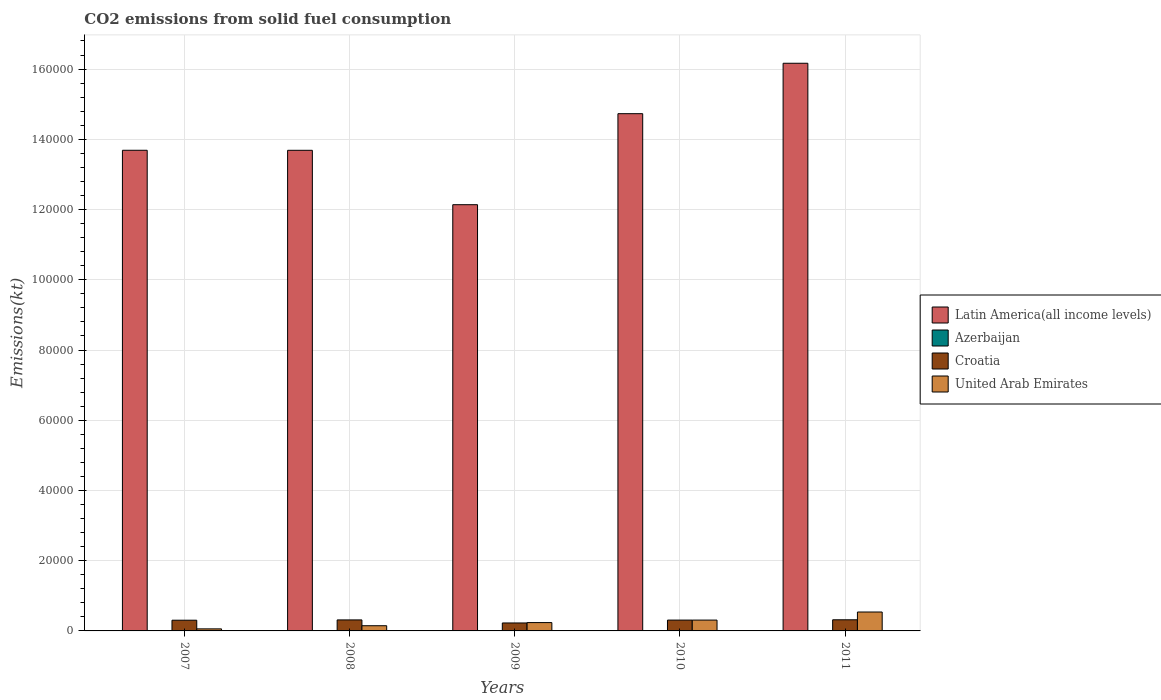Are the number of bars per tick equal to the number of legend labels?
Ensure brevity in your answer.  Yes. How many bars are there on the 5th tick from the left?
Make the answer very short. 4. What is the amount of CO2 emitted in Latin America(all income levels) in 2008?
Keep it short and to the point. 1.37e+05. Across all years, what is the maximum amount of CO2 emitted in Latin America(all income levels)?
Ensure brevity in your answer.  1.62e+05. Across all years, what is the minimum amount of CO2 emitted in Croatia?
Offer a terse response. 2266.21. In which year was the amount of CO2 emitted in Azerbaijan maximum?
Make the answer very short. 2007. In which year was the amount of CO2 emitted in Croatia minimum?
Make the answer very short. 2009. What is the total amount of CO2 emitted in United Arab Emirates in the graph?
Your answer should be very brief. 1.29e+04. What is the difference between the amount of CO2 emitted in Croatia in 2010 and that in 2011?
Give a very brief answer. -80.67. What is the difference between the amount of CO2 emitted in Latin America(all income levels) in 2011 and the amount of CO2 emitted in Azerbaijan in 2009?
Keep it short and to the point. 1.62e+05. What is the average amount of CO2 emitted in Latin America(all income levels) per year?
Offer a terse response. 1.41e+05. In the year 2011, what is the difference between the amount of CO2 emitted in United Arab Emirates and amount of CO2 emitted in Azerbaijan?
Ensure brevity in your answer.  5364.82. What is the ratio of the amount of CO2 emitted in Croatia in 2007 to that in 2011?
Offer a terse response. 0.96. Is the amount of CO2 emitted in United Arab Emirates in 2007 less than that in 2010?
Provide a short and direct response. Yes. What is the difference between the highest and the second highest amount of CO2 emitted in Azerbaijan?
Give a very brief answer. 0. What is the difference between the highest and the lowest amount of CO2 emitted in United Arab Emirates?
Your response must be concise. 4803.77. What does the 2nd bar from the left in 2010 represents?
Your answer should be compact. Azerbaijan. What does the 4th bar from the right in 2007 represents?
Keep it short and to the point. Latin America(all income levels). Is it the case that in every year, the sum of the amount of CO2 emitted in United Arab Emirates and amount of CO2 emitted in Azerbaijan is greater than the amount of CO2 emitted in Latin America(all income levels)?
Offer a terse response. No. Are all the bars in the graph horizontal?
Your response must be concise. No. What is the difference between two consecutive major ticks on the Y-axis?
Offer a very short reply. 2.00e+04. Does the graph contain any zero values?
Your answer should be very brief. No. Does the graph contain grids?
Give a very brief answer. Yes. How many legend labels are there?
Keep it short and to the point. 4. What is the title of the graph?
Make the answer very short. CO2 emissions from solid fuel consumption. What is the label or title of the Y-axis?
Offer a terse response. Emissions(kt). What is the Emissions(kt) in Latin America(all income levels) in 2007?
Give a very brief answer. 1.37e+05. What is the Emissions(kt) of Azerbaijan in 2007?
Give a very brief answer. 22. What is the Emissions(kt) of Croatia in 2007?
Your answer should be very brief. 3050.94. What is the Emissions(kt) in United Arab Emirates in 2007?
Offer a very short reply. 583.05. What is the Emissions(kt) of Latin America(all income levels) in 2008?
Provide a succinct answer. 1.37e+05. What is the Emissions(kt) in Azerbaijan in 2008?
Offer a terse response. 14.67. What is the Emissions(kt) of Croatia in 2008?
Provide a succinct answer. 3135.28. What is the Emissions(kt) of United Arab Emirates in 2008?
Your answer should be very brief. 1477.8. What is the Emissions(kt) in Latin America(all income levels) in 2009?
Make the answer very short. 1.21e+05. What is the Emissions(kt) in Azerbaijan in 2009?
Offer a very short reply. 14.67. What is the Emissions(kt) in Croatia in 2009?
Your answer should be compact. 2266.21. What is the Emissions(kt) in United Arab Emirates in 2009?
Your response must be concise. 2372.55. What is the Emissions(kt) of Latin America(all income levels) in 2010?
Your response must be concise. 1.47e+05. What is the Emissions(kt) of Azerbaijan in 2010?
Offer a terse response. 22. What is the Emissions(kt) in Croatia in 2010?
Offer a terse response. 3087.61. What is the Emissions(kt) of United Arab Emirates in 2010?
Provide a short and direct response. 3083.95. What is the Emissions(kt) of Latin America(all income levels) in 2011?
Your answer should be very brief. 1.62e+05. What is the Emissions(kt) in Azerbaijan in 2011?
Your response must be concise. 22. What is the Emissions(kt) of Croatia in 2011?
Your answer should be very brief. 3168.29. What is the Emissions(kt) in United Arab Emirates in 2011?
Give a very brief answer. 5386.82. Across all years, what is the maximum Emissions(kt) of Latin America(all income levels)?
Provide a succinct answer. 1.62e+05. Across all years, what is the maximum Emissions(kt) in Azerbaijan?
Offer a very short reply. 22. Across all years, what is the maximum Emissions(kt) of Croatia?
Your response must be concise. 3168.29. Across all years, what is the maximum Emissions(kt) of United Arab Emirates?
Your answer should be compact. 5386.82. Across all years, what is the minimum Emissions(kt) in Latin America(all income levels)?
Keep it short and to the point. 1.21e+05. Across all years, what is the minimum Emissions(kt) of Azerbaijan?
Your response must be concise. 14.67. Across all years, what is the minimum Emissions(kt) of Croatia?
Provide a succinct answer. 2266.21. Across all years, what is the minimum Emissions(kt) in United Arab Emirates?
Keep it short and to the point. 583.05. What is the total Emissions(kt) in Latin America(all income levels) in the graph?
Your answer should be very brief. 7.04e+05. What is the total Emissions(kt) in Azerbaijan in the graph?
Offer a terse response. 95.34. What is the total Emissions(kt) of Croatia in the graph?
Offer a terse response. 1.47e+04. What is the total Emissions(kt) in United Arab Emirates in the graph?
Your answer should be very brief. 1.29e+04. What is the difference between the Emissions(kt) in Latin America(all income levels) in 2007 and that in 2008?
Keep it short and to the point. 7.81. What is the difference between the Emissions(kt) of Azerbaijan in 2007 and that in 2008?
Provide a short and direct response. 7.33. What is the difference between the Emissions(kt) of Croatia in 2007 and that in 2008?
Your response must be concise. -84.34. What is the difference between the Emissions(kt) in United Arab Emirates in 2007 and that in 2008?
Provide a short and direct response. -894.75. What is the difference between the Emissions(kt) of Latin America(all income levels) in 2007 and that in 2009?
Offer a very short reply. 1.55e+04. What is the difference between the Emissions(kt) in Azerbaijan in 2007 and that in 2009?
Ensure brevity in your answer.  7.33. What is the difference between the Emissions(kt) of Croatia in 2007 and that in 2009?
Ensure brevity in your answer.  784.74. What is the difference between the Emissions(kt) in United Arab Emirates in 2007 and that in 2009?
Ensure brevity in your answer.  -1789.5. What is the difference between the Emissions(kt) in Latin America(all income levels) in 2007 and that in 2010?
Ensure brevity in your answer.  -1.04e+04. What is the difference between the Emissions(kt) of Croatia in 2007 and that in 2010?
Your answer should be compact. -36.67. What is the difference between the Emissions(kt) of United Arab Emirates in 2007 and that in 2010?
Make the answer very short. -2500.89. What is the difference between the Emissions(kt) in Latin America(all income levels) in 2007 and that in 2011?
Provide a succinct answer. -2.48e+04. What is the difference between the Emissions(kt) of Croatia in 2007 and that in 2011?
Keep it short and to the point. -117.34. What is the difference between the Emissions(kt) in United Arab Emirates in 2007 and that in 2011?
Ensure brevity in your answer.  -4803.77. What is the difference between the Emissions(kt) in Latin America(all income levels) in 2008 and that in 2009?
Your answer should be compact. 1.55e+04. What is the difference between the Emissions(kt) in Croatia in 2008 and that in 2009?
Provide a succinct answer. 869.08. What is the difference between the Emissions(kt) in United Arab Emirates in 2008 and that in 2009?
Your answer should be very brief. -894.75. What is the difference between the Emissions(kt) in Latin America(all income levels) in 2008 and that in 2010?
Make the answer very short. -1.04e+04. What is the difference between the Emissions(kt) in Azerbaijan in 2008 and that in 2010?
Ensure brevity in your answer.  -7.33. What is the difference between the Emissions(kt) in Croatia in 2008 and that in 2010?
Provide a succinct answer. 47.67. What is the difference between the Emissions(kt) of United Arab Emirates in 2008 and that in 2010?
Your answer should be very brief. -1606.15. What is the difference between the Emissions(kt) in Latin America(all income levels) in 2008 and that in 2011?
Ensure brevity in your answer.  -2.48e+04. What is the difference between the Emissions(kt) in Azerbaijan in 2008 and that in 2011?
Give a very brief answer. -7.33. What is the difference between the Emissions(kt) of Croatia in 2008 and that in 2011?
Provide a succinct answer. -33. What is the difference between the Emissions(kt) in United Arab Emirates in 2008 and that in 2011?
Your answer should be very brief. -3909.02. What is the difference between the Emissions(kt) of Latin America(all income levels) in 2009 and that in 2010?
Your answer should be compact. -2.59e+04. What is the difference between the Emissions(kt) of Azerbaijan in 2009 and that in 2010?
Ensure brevity in your answer.  -7.33. What is the difference between the Emissions(kt) of Croatia in 2009 and that in 2010?
Give a very brief answer. -821.41. What is the difference between the Emissions(kt) in United Arab Emirates in 2009 and that in 2010?
Provide a short and direct response. -711.4. What is the difference between the Emissions(kt) in Latin America(all income levels) in 2009 and that in 2011?
Provide a succinct answer. -4.03e+04. What is the difference between the Emissions(kt) of Azerbaijan in 2009 and that in 2011?
Offer a terse response. -7.33. What is the difference between the Emissions(kt) of Croatia in 2009 and that in 2011?
Offer a terse response. -902.08. What is the difference between the Emissions(kt) of United Arab Emirates in 2009 and that in 2011?
Provide a short and direct response. -3014.27. What is the difference between the Emissions(kt) of Latin America(all income levels) in 2010 and that in 2011?
Your response must be concise. -1.44e+04. What is the difference between the Emissions(kt) in Croatia in 2010 and that in 2011?
Provide a short and direct response. -80.67. What is the difference between the Emissions(kt) of United Arab Emirates in 2010 and that in 2011?
Give a very brief answer. -2302.88. What is the difference between the Emissions(kt) of Latin America(all income levels) in 2007 and the Emissions(kt) of Azerbaijan in 2008?
Provide a short and direct response. 1.37e+05. What is the difference between the Emissions(kt) in Latin America(all income levels) in 2007 and the Emissions(kt) in Croatia in 2008?
Your answer should be compact. 1.34e+05. What is the difference between the Emissions(kt) in Latin America(all income levels) in 2007 and the Emissions(kt) in United Arab Emirates in 2008?
Your answer should be compact. 1.35e+05. What is the difference between the Emissions(kt) in Azerbaijan in 2007 and the Emissions(kt) in Croatia in 2008?
Offer a terse response. -3113.28. What is the difference between the Emissions(kt) of Azerbaijan in 2007 and the Emissions(kt) of United Arab Emirates in 2008?
Ensure brevity in your answer.  -1455.8. What is the difference between the Emissions(kt) of Croatia in 2007 and the Emissions(kt) of United Arab Emirates in 2008?
Your response must be concise. 1573.14. What is the difference between the Emissions(kt) of Latin America(all income levels) in 2007 and the Emissions(kt) of Azerbaijan in 2009?
Give a very brief answer. 1.37e+05. What is the difference between the Emissions(kt) in Latin America(all income levels) in 2007 and the Emissions(kt) in Croatia in 2009?
Give a very brief answer. 1.35e+05. What is the difference between the Emissions(kt) of Latin America(all income levels) in 2007 and the Emissions(kt) of United Arab Emirates in 2009?
Your answer should be compact. 1.35e+05. What is the difference between the Emissions(kt) of Azerbaijan in 2007 and the Emissions(kt) of Croatia in 2009?
Keep it short and to the point. -2244.2. What is the difference between the Emissions(kt) of Azerbaijan in 2007 and the Emissions(kt) of United Arab Emirates in 2009?
Your response must be concise. -2350.55. What is the difference between the Emissions(kt) in Croatia in 2007 and the Emissions(kt) in United Arab Emirates in 2009?
Your answer should be compact. 678.39. What is the difference between the Emissions(kt) of Latin America(all income levels) in 2007 and the Emissions(kt) of Azerbaijan in 2010?
Your answer should be very brief. 1.37e+05. What is the difference between the Emissions(kt) in Latin America(all income levels) in 2007 and the Emissions(kt) in Croatia in 2010?
Your answer should be very brief. 1.34e+05. What is the difference between the Emissions(kt) of Latin America(all income levels) in 2007 and the Emissions(kt) of United Arab Emirates in 2010?
Ensure brevity in your answer.  1.34e+05. What is the difference between the Emissions(kt) in Azerbaijan in 2007 and the Emissions(kt) in Croatia in 2010?
Give a very brief answer. -3065.61. What is the difference between the Emissions(kt) of Azerbaijan in 2007 and the Emissions(kt) of United Arab Emirates in 2010?
Your response must be concise. -3061.95. What is the difference between the Emissions(kt) of Croatia in 2007 and the Emissions(kt) of United Arab Emirates in 2010?
Make the answer very short. -33. What is the difference between the Emissions(kt) of Latin America(all income levels) in 2007 and the Emissions(kt) of Azerbaijan in 2011?
Offer a terse response. 1.37e+05. What is the difference between the Emissions(kt) of Latin America(all income levels) in 2007 and the Emissions(kt) of Croatia in 2011?
Your answer should be very brief. 1.34e+05. What is the difference between the Emissions(kt) of Latin America(all income levels) in 2007 and the Emissions(kt) of United Arab Emirates in 2011?
Ensure brevity in your answer.  1.31e+05. What is the difference between the Emissions(kt) of Azerbaijan in 2007 and the Emissions(kt) of Croatia in 2011?
Ensure brevity in your answer.  -3146.29. What is the difference between the Emissions(kt) in Azerbaijan in 2007 and the Emissions(kt) in United Arab Emirates in 2011?
Your answer should be very brief. -5364.82. What is the difference between the Emissions(kt) of Croatia in 2007 and the Emissions(kt) of United Arab Emirates in 2011?
Keep it short and to the point. -2335.88. What is the difference between the Emissions(kt) of Latin America(all income levels) in 2008 and the Emissions(kt) of Azerbaijan in 2009?
Your response must be concise. 1.37e+05. What is the difference between the Emissions(kt) in Latin America(all income levels) in 2008 and the Emissions(kt) in Croatia in 2009?
Keep it short and to the point. 1.35e+05. What is the difference between the Emissions(kt) in Latin America(all income levels) in 2008 and the Emissions(kt) in United Arab Emirates in 2009?
Give a very brief answer. 1.34e+05. What is the difference between the Emissions(kt) of Azerbaijan in 2008 and the Emissions(kt) of Croatia in 2009?
Provide a short and direct response. -2251.54. What is the difference between the Emissions(kt) of Azerbaijan in 2008 and the Emissions(kt) of United Arab Emirates in 2009?
Ensure brevity in your answer.  -2357.88. What is the difference between the Emissions(kt) in Croatia in 2008 and the Emissions(kt) in United Arab Emirates in 2009?
Your answer should be compact. 762.74. What is the difference between the Emissions(kt) in Latin America(all income levels) in 2008 and the Emissions(kt) in Azerbaijan in 2010?
Offer a very short reply. 1.37e+05. What is the difference between the Emissions(kt) in Latin America(all income levels) in 2008 and the Emissions(kt) in Croatia in 2010?
Make the answer very short. 1.34e+05. What is the difference between the Emissions(kt) in Latin America(all income levels) in 2008 and the Emissions(kt) in United Arab Emirates in 2010?
Provide a short and direct response. 1.34e+05. What is the difference between the Emissions(kt) of Azerbaijan in 2008 and the Emissions(kt) of Croatia in 2010?
Your answer should be very brief. -3072.95. What is the difference between the Emissions(kt) of Azerbaijan in 2008 and the Emissions(kt) of United Arab Emirates in 2010?
Make the answer very short. -3069.28. What is the difference between the Emissions(kt) of Croatia in 2008 and the Emissions(kt) of United Arab Emirates in 2010?
Provide a short and direct response. 51.34. What is the difference between the Emissions(kt) of Latin America(all income levels) in 2008 and the Emissions(kt) of Azerbaijan in 2011?
Give a very brief answer. 1.37e+05. What is the difference between the Emissions(kt) in Latin America(all income levels) in 2008 and the Emissions(kt) in Croatia in 2011?
Give a very brief answer. 1.34e+05. What is the difference between the Emissions(kt) in Latin America(all income levels) in 2008 and the Emissions(kt) in United Arab Emirates in 2011?
Make the answer very short. 1.31e+05. What is the difference between the Emissions(kt) in Azerbaijan in 2008 and the Emissions(kt) in Croatia in 2011?
Provide a succinct answer. -3153.62. What is the difference between the Emissions(kt) of Azerbaijan in 2008 and the Emissions(kt) of United Arab Emirates in 2011?
Provide a short and direct response. -5372.15. What is the difference between the Emissions(kt) in Croatia in 2008 and the Emissions(kt) in United Arab Emirates in 2011?
Make the answer very short. -2251.54. What is the difference between the Emissions(kt) in Latin America(all income levels) in 2009 and the Emissions(kt) in Azerbaijan in 2010?
Keep it short and to the point. 1.21e+05. What is the difference between the Emissions(kt) in Latin America(all income levels) in 2009 and the Emissions(kt) in Croatia in 2010?
Provide a short and direct response. 1.18e+05. What is the difference between the Emissions(kt) in Latin America(all income levels) in 2009 and the Emissions(kt) in United Arab Emirates in 2010?
Keep it short and to the point. 1.18e+05. What is the difference between the Emissions(kt) in Azerbaijan in 2009 and the Emissions(kt) in Croatia in 2010?
Provide a succinct answer. -3072.95. What is the difference between the Emissions(kt) of Azerbaijan in 2009 and the Emissions(kt) of United Arab Emirates in 2010?
Provide a succinct answer. -3069.28. What is the difference between the Emissions(kt) in Croatia in 2009 and the Emissions(kt) in United Arab Emirates in 2010?
Keep it short and to the point. -817.74. What is the difference between the Emissions(kt) in Latin America(all income levels) in 2009 and the Emissions(kt) in Azerbaijan in 2011?
Offer a terse response. 1.21e+05. What is the difference between the Emissions(kt) in Latin America(all income levels) in 2009 and the Emissions(kt) in Croatia in 2011?
Give a very brief answer. 1.18e+05. What is the difference between the Emissions(kt) in Latin America(all income levels) in 2009 and the Emissions(kt) in United Arab Emirates in 2011?
Offer a terse response. 1.16e+05. What is the difference between the Emissions(kt) in Azerbaijan in 2009 and the Emissions(kt) in Croatia in 2011?
Ensure brevity in your answer.  -3153.62. What is the difference between the Emissions(kt) in Azerbaijan in 2009 and the Emissions(kt) in United Arab Emirates in 2011?
Provide a succinct answer. -5372.15. What is the difference between the Emissions(kt) in Croatia in 2009 and the Emissions(kt) in United Arab Emirates in 2011?
Your answer should be very brief. -3120.62. What is the difference between the Emissions(kt) in Latin America(all income levels) in 2010 and the Emissions(kt) in Azerbaijan in 2011?
Your answer should be very brief. 1.47e+05. What is the difference between the Emissions(kt) of Latin America(all income levels) in 2010 and the Emissions(kt) of Croatia in 2011?
Give a very brief answer. 1.44e+05. What is the difference between the Emissions(kt) in Latin America(all income levels) in 2010 and the Emissions(kt) in United Arab Emirates in 2011?
Keep it short and to the point. 1.42e+05. What is the difference between the Emissions(kt) of Azerbaijan in 2010 and the Emissions(kt) of Croatia in 2011?
Your answer should be compact. -3146.29. What is the difference between the Emissions(kt) in Azerbaijan in 2010 and the Emissions(kt) in United Arab Emirates in 2011?
Ensure brevity in your answer.  -5364.82. What is the difference between the Emissions(kt) of Croatia in 2010 and the Emissions(kt) of United Arab Emirates in 2011?
Offer a very short reply. -2299.21. What is the average Emissions(kt) in Latin America(all income levels) per year?
Your response must be concise. 1.41e+05. What is the average Emissions(kt) of Azerbaijan per year?
Provide a short and direct response. 19.07. What is the average Emissions(kt) in Croatia per year?
Make the answer very short. 2941.67. What is the average Emissions(kt) in United Arab Emirates per year?
Your answer should be compact. 2580.83. In the year 2007, what is the difference between the Emissions(kt) of Latin America(all income levels) and Emissions(kt) of Azerbaijan?
Your answer should be compact. 1.37e+05. In the year 2007, what is the difference between the Emissions(kt) of Latin America(all income levels) and Emissions(kt) of Croatia?
Keep it short and to the point. 1.34e+05. In the year 2007, what is the difference between the Emissions(kt) in Latin America(all income levels) and Emissions(kt) in United Arab Emirates?
Your answer should be compact. 1.36e+05. In the year 2007, what is the difference between the Emissions(kt) in Azerbaijan and Emissions(kt) in Croatia?
Keep it short and to the point. -3028.94. In the year 2007, what is the difference between the Emissions(kt) in Azerbaijan and Emissions(kt) in United Arab Emirates?
Make the answer very short. -561.05. In the year 2007, what is the difference between the Emissions(kt) of Croatia and Emissions(kt) of United Arab Emirates?
Keep it short and to the point. 2467.89. In the year 2008, what is the difference between the Emissions(kt) of Latin America(all income levels) and Emissions(kt) of Azerbaijan?
Provide a succinct answer. 1.37e+05. In the year 2008, what is the difference between the Emissions(kt) of Latin America(all income levels) and Emissions(kt) of Croatia?
Provide a succinct answer. 1.34e+05. In the year 2008, what is the difference between the Emissions(kt) in Latin America(all income levels) and Emissions(kt) in United Arab Emirates?
Your answer should be compact. 1.35e+05. In the year 2008, what is the difference between the Emissions(kt) of Azerbaijan and Emissions(kt) of Croatia?
Your answer should be very brief. -3120.62. In the year 2008, what is the difference between the Emissions(kt) in Azerbaijan and Emissions(kt) in United Arab Emirates?
Offer a very short reply. -1463.13. In the year 2008, what is the difference between the Emissions(kt) in Croatia and Emissions(kt) in United Arab Emirates?
Your answer should be compact. 1657.48. In the year 2009, what is the difference between the Emissions(kt) in Latin America(all income levels) and Emissions(kt) in Azerbaijan?
Offer a very short reply. 1.21e+05. In the year 2009, what is the difference between the Emissions(kt) of Latin America(all income levels) and Emissions(kt) of Croatia?
Offer a terse response. 1.19e+05. In the year 2009, what is the difference between the Emissions(kt) in Latin America(all income levels) and Emissions(kt) in United Arab Emirates?
Provide a short and direct response. 1.19e+05. In the year 2009, what is the difference between the Emissions(kt) of Azerbaijan and Emissions(kt) of Croatia?
Make the answer very short. -2251.54. In the year 2009, what is the difference between the Emissions(kt) of Azerbaijan and Emissions(kt) of United Arab Emirates?
Make the answer very short. -2357.88. In the year 2009, what is the difference between the Emissions(kt) of Croatia and Emissions(kt) of United Arab Emirates?
Offer a terse response. -106.34. In the year 2010, what is the difference between the Emissions(kt) in Latin America(all income levels) and Emissions(kt) in Azerbaijan?
Your answer should be compact. 1.47e+05. In the year 2010, what is the difference between the Emissions(kt) of Latin America(all income levels) and Emissions(kt) of Croatia?
Offer a terse response. 1.44e+05. In the year 2010, what is the difference between the Emissions(kt) in Latin America(all income levels) and Emissions(kt) in United Arab Emirates?
Provide a short and direct response. 1.44e+05. In the year 2010, what is the difference between the Emissions(kt) of Azerbaijan and Emissions(kt) of Croatia?
Keep it short and to the point. -3065.61. In the year 2010, what is the difference between the Emissions(kt) in Azerbaijan and Emissions(kt) in United Arab Emirates?
Keep it short and to the point. -3061.95. In the year 2010, what is the difference between the Emissions(kt) of Croatia and Emissions(kt) of United Arab Emirates?
Provide a short and direct response. 3.67. In the year 2011, what is the difference between the Emissions(kt) of Latin America(all income levels) and Emissions(kt) of Azerbaijan?
Provide a succinct answer. 1.62e+05. In the year 2011, what is the difference between the Emissions(kt) in Latin America(all income levels) and Emissions(kt) in Croatia?
Make the answer very short. 1.58e+05. In the year 2011, what is the difference between the Emissions(kt) of Latin America(all income levels) and Emissions(kt) of United Arab Emirates?
Provide a short and direct response. 1.56e+05. In the year 2011, what is the difference between the Emissions(kt) in Azerbaijan and Emissions(kt) in Croatia?
Make the answer very short. -3146.29. In the year 2011, what is the difference between the Emissions(kt) in Azerbaijan and Emissions(kt) in United Arab Emirates?
Give a very brief answer. -5364.82. In the year 2011, what is the difference between the Emissions(kt) of Croatia and Emissions(kt) of United Arab Emirates?
Your response must be concise. -2218.53. What is the ratio of the Emissions(kt) of Latin America(all income levels) in 2007 to that in 2008?
Keep it short and to the point. 1. What is the ratio of the Emissions(kt) of Azerbaijan in 2007 to that in 2008?
Make the answer very short. 1.5. What is the ratio of the Emissions(kt) in Croatia in 2007 to that in 2008?
Your response must be concise. 0.97. What is the ratio of the Emissions(kt) of United Arab Emirates in 2007 to that in 2008?
Your answer should be compact. 0.39. What is the ratio of the Emissions(kt) in Latin America(all income levels) in 2007 to that in 2009?
Offer a very short reply. 1.13. What is the ratio of the Emissions(kt) in Croatia in 2007 to that in 2009?
Offer a very short reply. 1.35. What is the ratio of the Emissions(kt) in United Arab Emirates in 2007 to that in 2009?
Keep it short and to the point. 0.25. What is the ratio of the Emissions(kt) of Latin America(all income levels) in 2007 to that in 2010?
Your answer should be very brief. 0.93. What is the ratio of the Emissions(kt) of United Arab Emirates in 2007 to that in 2010?
Keep it short and to the point. 0.19. What is the ratio of the Emissions(kt) of Latin America(all income levels) in 2007 to that in 2011?
Give a very brief answer. 0.85. What is the ratio of the Emissions(kt) of Croatia in 2007 to that in 2011?
Offer a terse response. 0.96. What is the ratio of the Emissions(kt) in United Arab Emirates in 2007 to that in 2011?
Offer a terse response. 0.11. What is the ratio of the Emissions(kt) of Latin America(all income levels) in 2008 to that in 2009?
Give a very brief answer. 1.13. What is the ratio of the Emissions(kt) of Croatia in 2008 to that in 2009?
Your answer should be compact. 1.38. What is the ratio of the Emissions(kt) of United Arab Emirates in 2008 to that in 2009?
Your answer should be very brief. 0.62. What is the ratio of the Emissions(kt) in Latin America(all income levels) in 2008 to that in 2010?
Ensure brevity in your answer.  0.93. What is the ratio of the Emissions(kt) of Croatia in 2008 to that in 2010?
Make the answer very short. 1.02. What is the ratio of the Emissions(kt) of United Arab Emirates in 2008 to that in 2010?
Offer a terse response. 0.48. What is the ratio of the Emissions(kt) of Latin America(all income levels) in 2008 to that in 2011?
Your response must be concise. 0.85. What is the ratio of the Emissions(kt) in Azerbaijan in 2008 to that in 2011?
Provide a succinct answer. 0.67. What is the ratio of the Emissions(kt) of United Arab Emirates in 2008 to that in 2011?
Your answer should be very brief. 0.27. What is the ratio of the Emissions(kt) in Latin America(all income levels) in 2009 to that in 2010?
Provide a short and direct response. 0.82. What is the ratio of the Emissions(kt) in Azerbaijan in 2009 to that in 2010?
Make the answer very short. 0.67. What is the ratio of the Emissions(kt) of Croatia in 2009 to that in 2010?
Offer a terse response. 0.73. What is the ratio of the Emissions(kt) in United Arab Emirates in 2009 to that in 2010?
Provide a short and direct response. 0.77. What is the ratio of the Emissions(kt) in Latin America(all income levels) in 2009 to that in 2011?
Your answer should be compact. 0.75. What is the ratio of the Emissions(kt) of Azerbaijan in 2009 to that in 2011?
Keep it short and to the point. 0.67. What is the ratio of the Emissions(kt) in Croatia in 2009 to that in 2011?
Your response must be concise. 0.72. What is the ratio of the Emissions(kt) of United Arab Emirates in 2009 to that in 2011?
Keep it short and to the point. 0.44. What is the ratio of the Emissions(kt) in Latin America(all income levels) in 2010 to that in 2011?
Provide a short and direct response. 0.91. What is the ratio of the Emissions(kt) in Azerbaijan in 2010 to that in 2011?
Give a very brief answer. 1. What is the ratio of the Emissions(kt) of Croatia in 2010 to that in 2011?
Offer a terse response. 0.97. What is the ratio of the Emissions(kt) in United Arab Emirates in 2010 to that in 2011?
Give a very brief answer. 0.57. What is the difference between the highest and the second highest Emissions(kt) of Latin America(all income levels)?
Keep it short and to the point. 1.44e+04. What is the difference between the highest and the second highest Emissions(kt) of Croatia?
Offer a very short reply. 33. What is the difference between the highest and the second highest Emissions(kt) of United Arab Emirates?
Keep it short and to the point. 2302.88. What is the difference between the highest and the lowest Emissions(kt) of Latin America(all income levels)?
Your answer should be compact. 4.03e+04. What is the difference between the highest and the lowest Emissions(kt) in Azerbaijan?
Offer a terse response. 7.33. What is the difference between the highest and the lowest Emissions(kt) in Croatia?
Your response must be concise. 902.08. What is the difference between the highest and the lowest Emissions(kt) of United Arab Emirates?
Provide a short and direct response. 4803.77. 